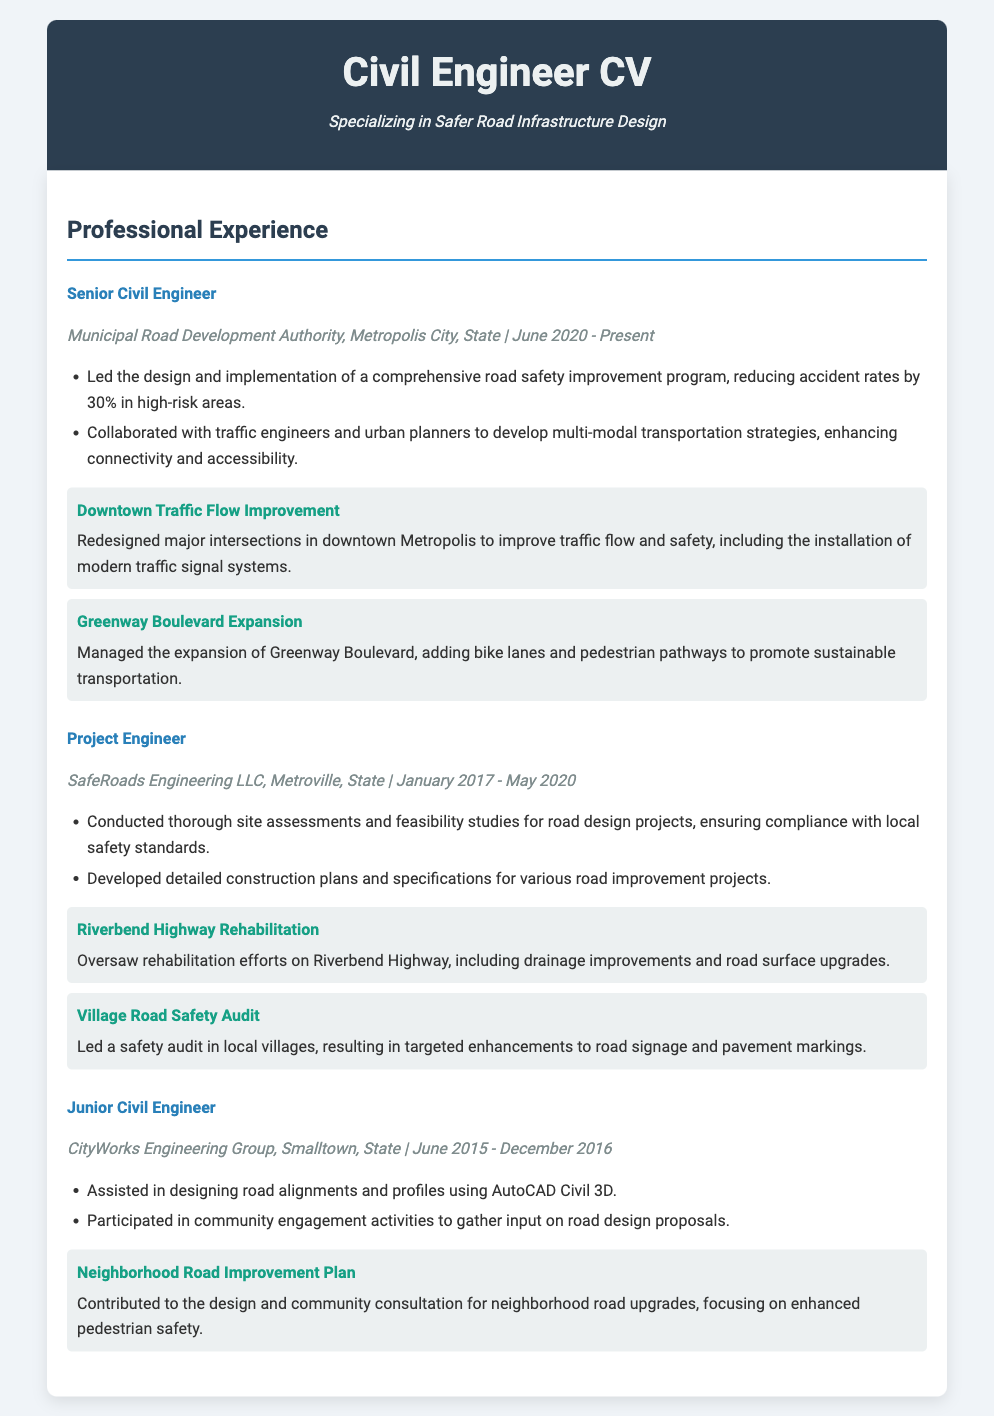what is the current job title of the individual? The job title is listed under the current position held by the individual, which is Senior Civil Engineer.
Answer: Senior Civil Engineer what organization is the individual currently working for? The organization is mentioned in the job details of the current position, which is Municipal Road Development Authority.
Answer: Municipal Road Development Authority when did the individual start working at their current job? The start date is included in the job details of the current position, which is June 2020.
Answer: June 2020 how many years did the individual work as a Project Engineer? The duration of service as a Project Engineer is from January 2017 to May 2020, which amounts to a little over 3 years.
Answer: 3 years what was the focus of the Downtown Traffic Flow Improvement project? The specific focus area of this project is provided in the project description, which is to improve traffic flow and safety.
Answer: Traffic flow and safety which project aimed at enhancing pedestrian safety? The project focused on pedestrian safety is mentioned in the Junior Civil Engineer position under the project section.
Answer: Neighborhood Road Improvement Plan what was a result of the road safety improvement program the individual led? The outcome of this program is quantified in the document, indicating a reduction of accident rates.
Answer: 30% reduction what skills did the individual exhibit in their Junior Civil Engineer role? The skills displayed are described in the job responsibilities, including designing road alignments and participating in community engagement activities.
Answer: Designing road alignments and community engagement activities what type of projects did the individual oversee as a Project Engineer? The types of projects are detailed in the role description; these are road design projects, including safety audits and rehabilitation efforts.
Answer: Road design projects 